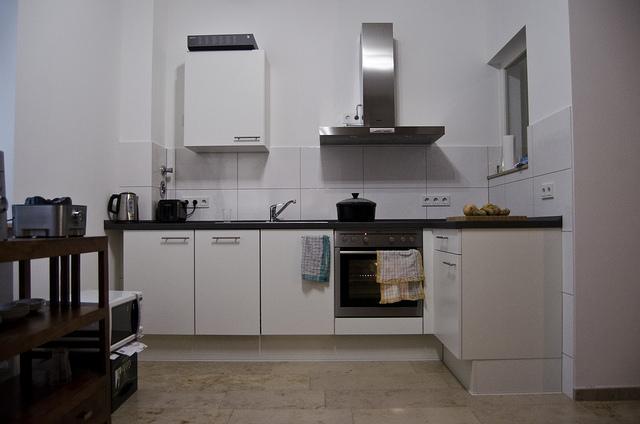How many wall cabinets are there?
Give a very brief answer. 1. How many ovens are there?
Give a very brief answer. 1. How many rolls of paper are on the shelf?
Give a very brief answer. 1. How many ovens are in the picture?
Give a very brief answer. 1. 